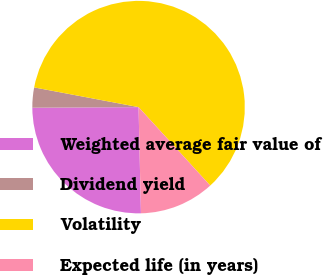Convert chart. <chart><loc_0><loc_0><loc_500><loc_500><pie_chart><fcel>Weighted average fair value of<fcel>Dividend yield<fcel>Volatility<fcel>Expected life (in years)<nl><fcel>25.27%<fcel>3.06%<fcel>60.25%<fcel>11.42%<nl></chart> 